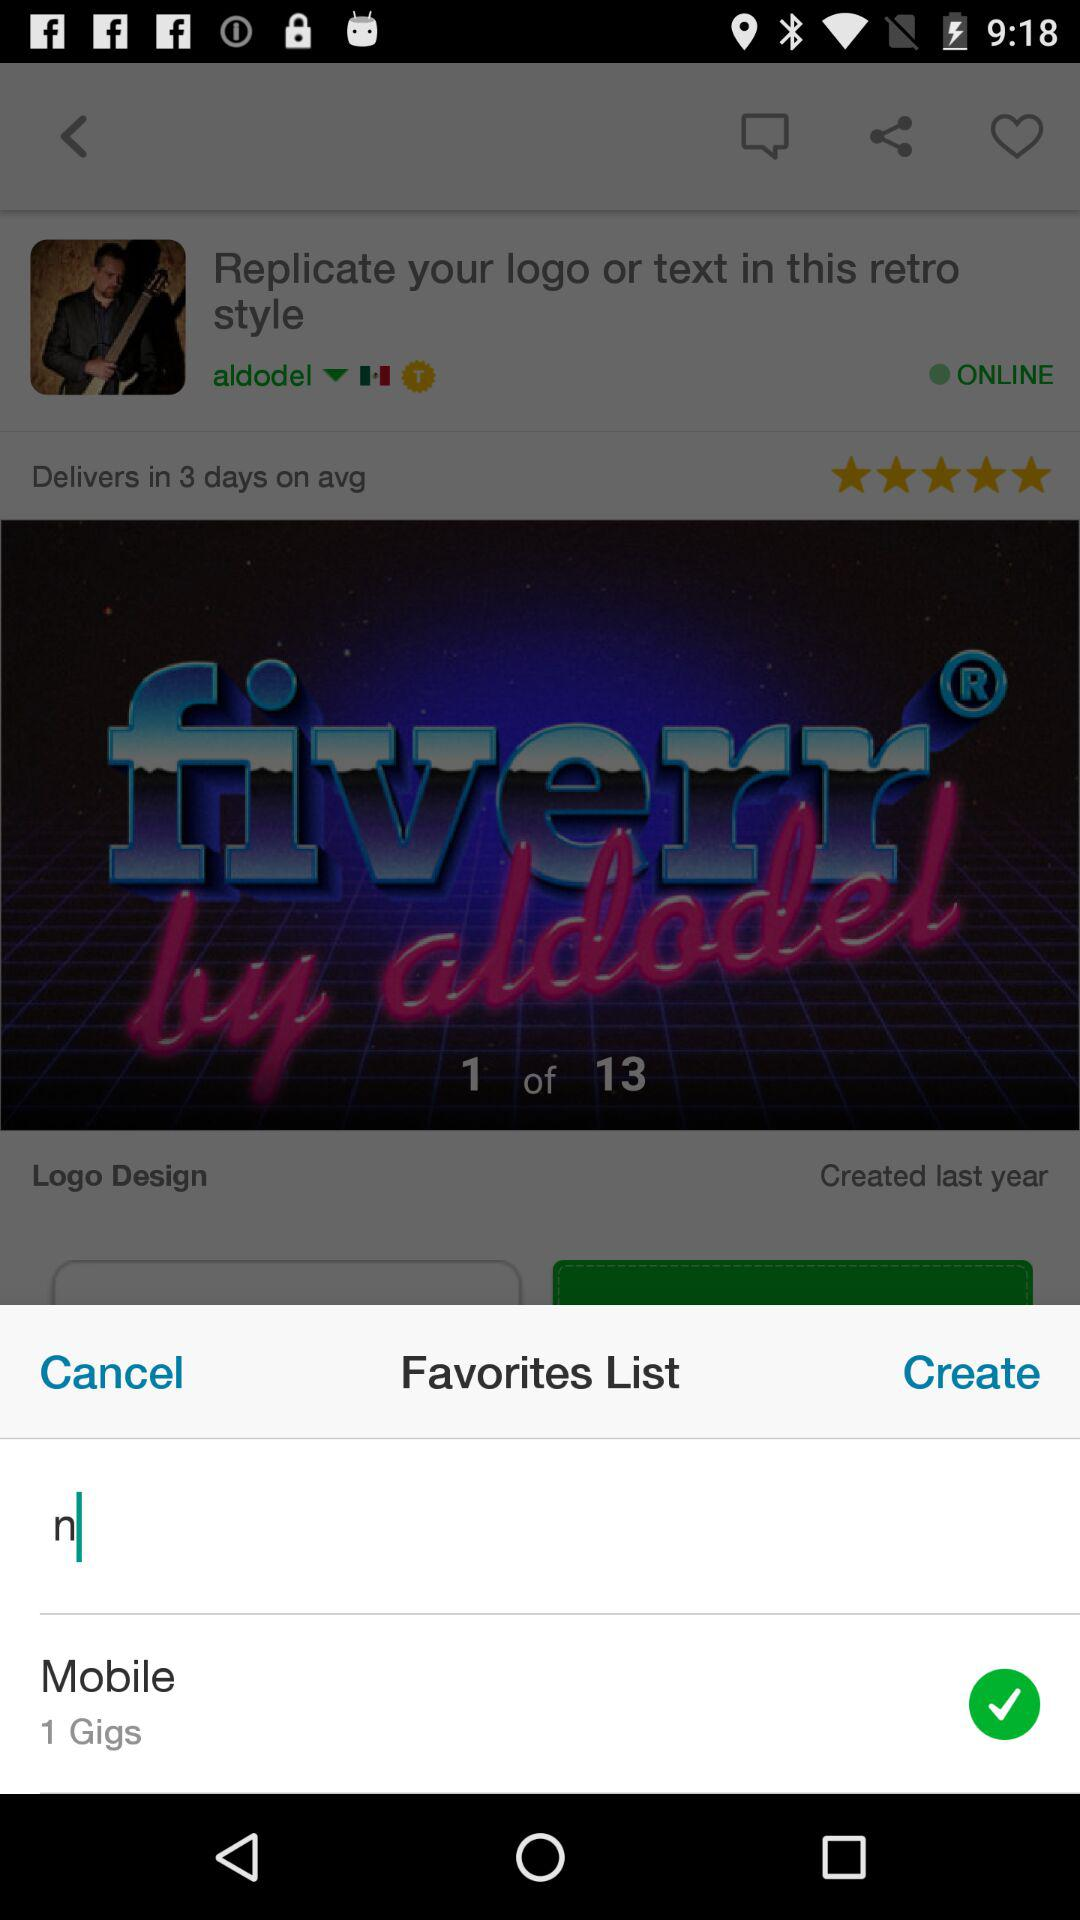How long has "aldodel" been online?
When the provided information is insufficient, respond with <no answer>. <no answer> 